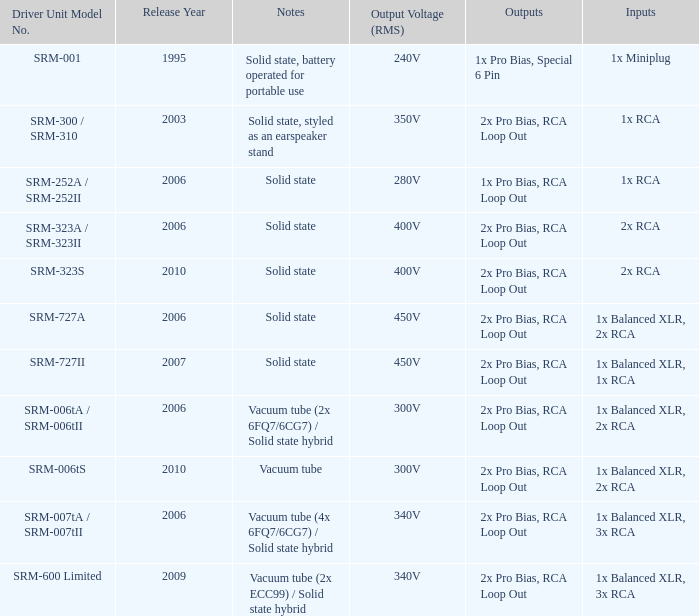What year were outputs is 2x pro bias, rca loop out and notes is vacuum tube released? 2010.0. Could you parse the entire table as a dict? {'header': ['Driver Unit Model No.', 'Release Year', 'Notes', 'Output Voltage (RMS)', 'Outputs', 'Inputs'], 'rows': [['SRM-001', '1995', 'Solid state, battery operated for portable use', '240V', '1x Pro Bias, Special 6 Pin', '1x Miniplug'], ['SRM-300 / SRM-310', '2003', 'Solid state, styled as an earspeaker stand', '350V', '2x Pro Bias, RCA Loop Out', '1x RCA'], ['SRM-252A / SRM-252II', '2006', 'Solid state', '280V', '1x Pro Bias, RCA Loop Out', '1x RCA'], ['SRM-323A / SRM-323II', '2006', 'Solid state', '400V', '2x Pro Bias, RCA Loop Out', '2x RCA'], ['SRM-323S', '2010', 'Solid state', '400V', '2x Pro Bias, RCA Loop Out', '2x RCA'], ['SRM-727A', '2006', 'Solid state', '450V', '2x Pro Bias, RCA Loop Out', '1x Balanced XLR, 2x RCA'], ['SRM-727II', '2007', 'Solid state', '450V', '2x Pro Bias, RCA Loop Out', '1x Balanced XLR, 1x RCA'], ['SRM-006tA / SRM-006tII', '2006', 'Vacuum tube (2x 6FQ7/6CG7) / Solid state hybrid', '300V', '2x Pro Bias, RCA Loop Out', '1x Balanced XLR, 2x RCA'], ['SRM-006tS', '2010', 'Vacuum tube', '300V', '2x Pro Bias, RCA Loop Out', '1x Balanced XLR, 2x RCA'], ['SRM-007tA / SRM-007tII', '2006', 'Vacuum tube (4x 6FQ7/6CG7) / Solid state hybrid', '340V', '2x Pro Bias, RCA Loop Out', '1x Balanced XLR, 3x RCA'], ['SRM-600 Limited', '2009', 'Vacuum tube (2x ECC99) / Solid state hybrid', '340V', '2x Pro Bias, RCA Loop Out', '1x Balanced XLR, 3x RCA']]} 